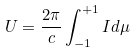<formula> <loc_0><loc_0><loc_500><loc_500>U = \frac { 2 \pi } { c } \int _ { - 1 } ^ { + 1 } I d \mu</formula> 